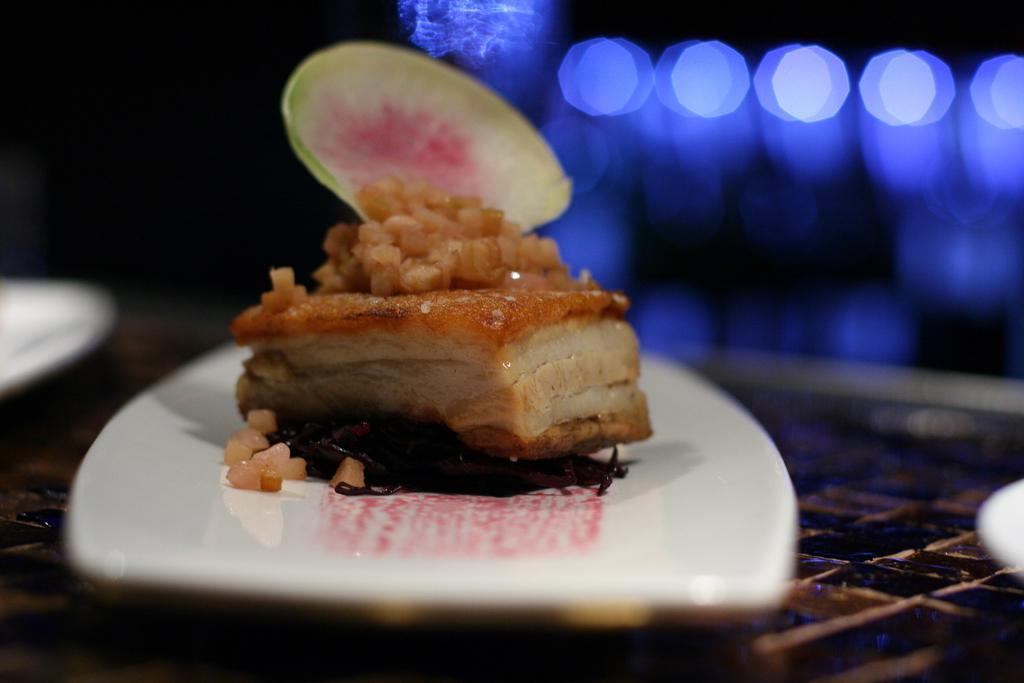In one or two sentences, can you explain what this image depicts? As we can see in the image in the front there is a table. On table there are plates and dish. The background is blurred. 